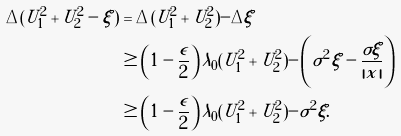Convert formula to latex. <formula><loc_0><loc_0><loc_500><loc_500>\Delta ( U _ { 1 } ^ { 2 } + U _ { 2 } ^ { 2 } - \xi ) & = \Delta ( U _ { 1 } ^ { 2 } + U _ { 2 } ^ { 2 } ) - \Delta \xi \\ & \geq \left ( 1 - \frac { \epsilon } { 2 } \right ) \lambda _ { 0 } ( U _ { 1 } ^ { 2 } + U _ { 2 } ^ { 2 } ) - \left ( \sigma ^ { 2 } \xi - \frac { \sigma \xi } { | x | } \right ) \\ & \geq \left ( 1 - \frac { \epsilon } { 2 } \right ) \lambda _ { 0 } ( U _ { 1 } ^ { 2 } + U _ { 2 } ^ { 2 } ) - \sigma ^ { 2 } \xi .</formula> 